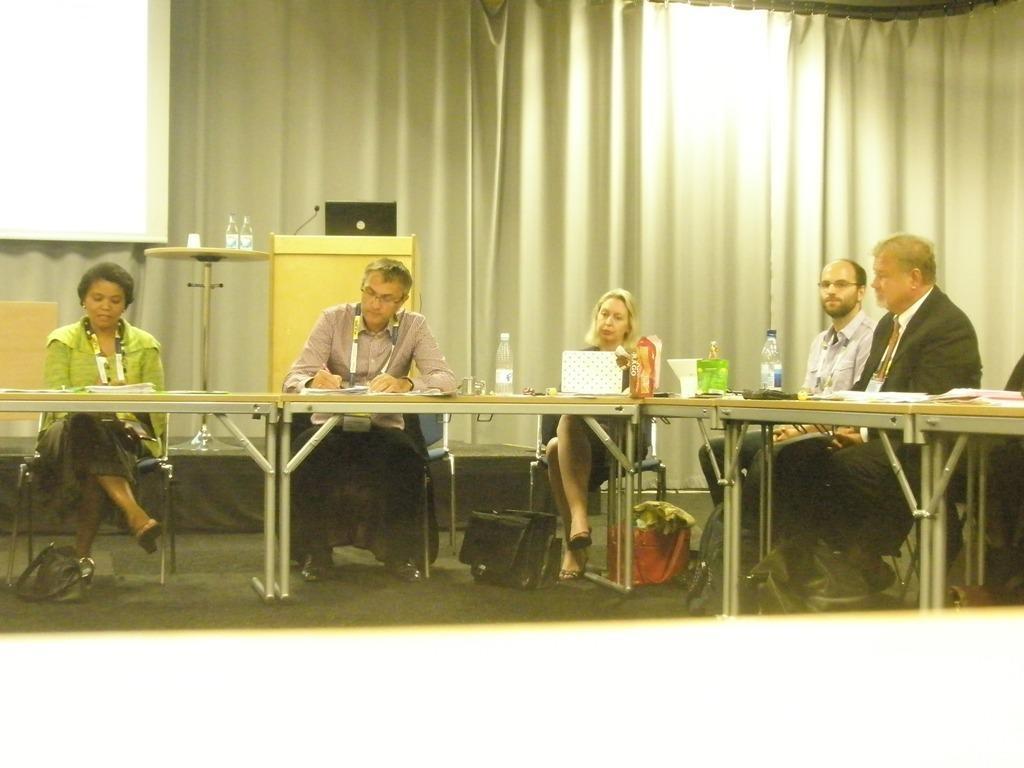How would you summarize this image in a sentence or two? In this image I can see few persons sitting on the chairs. I can see few tables. I can see a podium. There is a laptop on the podium. I can see two bottles on the table. In the background I can see a curtain. 